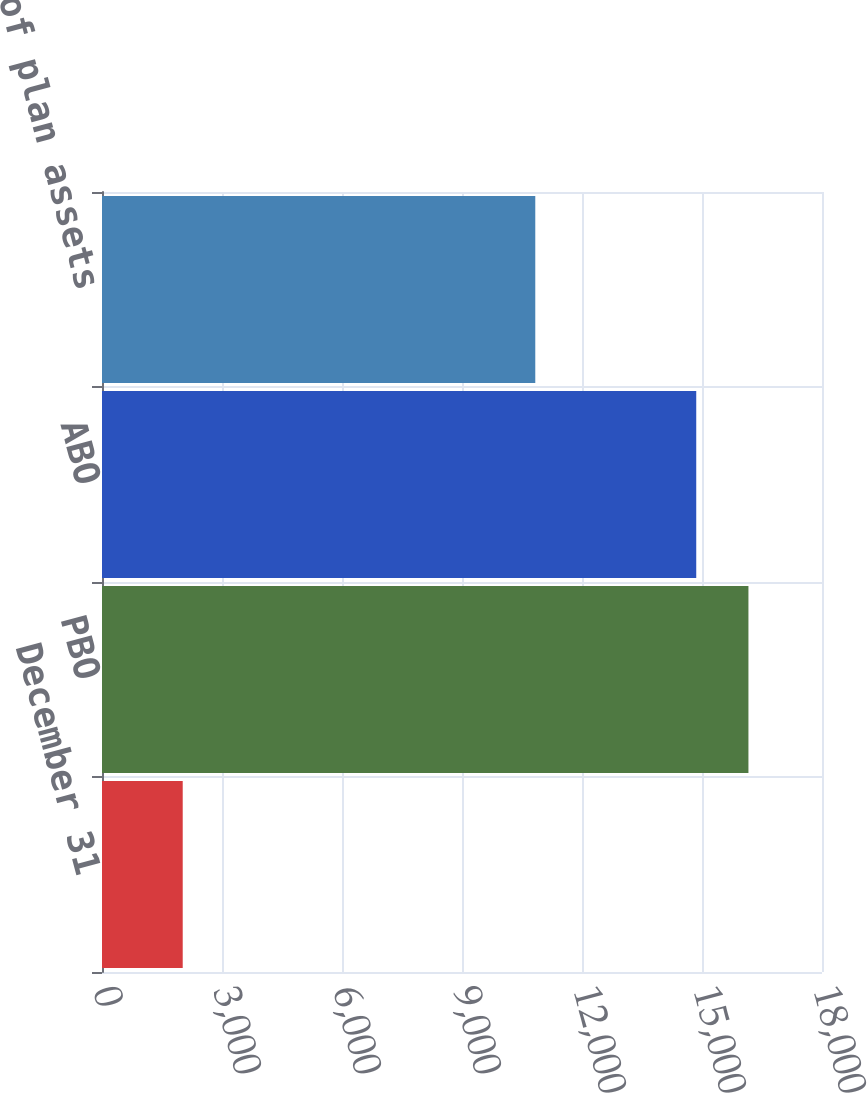<chart> <loc_0><loc_0><loc_500><loc_500><bar_chart><fcel>December 31<fcel>PBO<fcel>ABO<fcel>Fair value of plan assets<nl><fcel>2018<fcel>16160.9<fcel>14856<fcel>10832<nl></chart> 